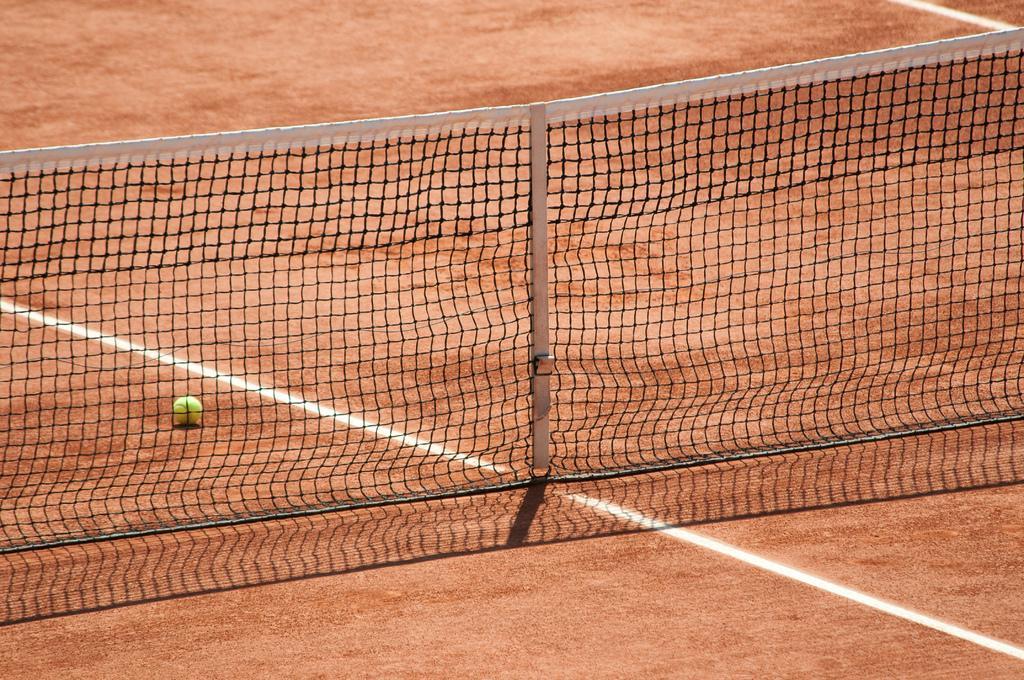Please provide a concise description of this image. In this image we can see the netball and also the ground. 